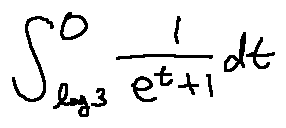<formula> <loc_0><loc_0><loc_500><loc_500>\int \lim i t s _ { \log 3 } ^ { 0 } \frac { 1 } { e ^ { t } + 1 } d t</formula> 